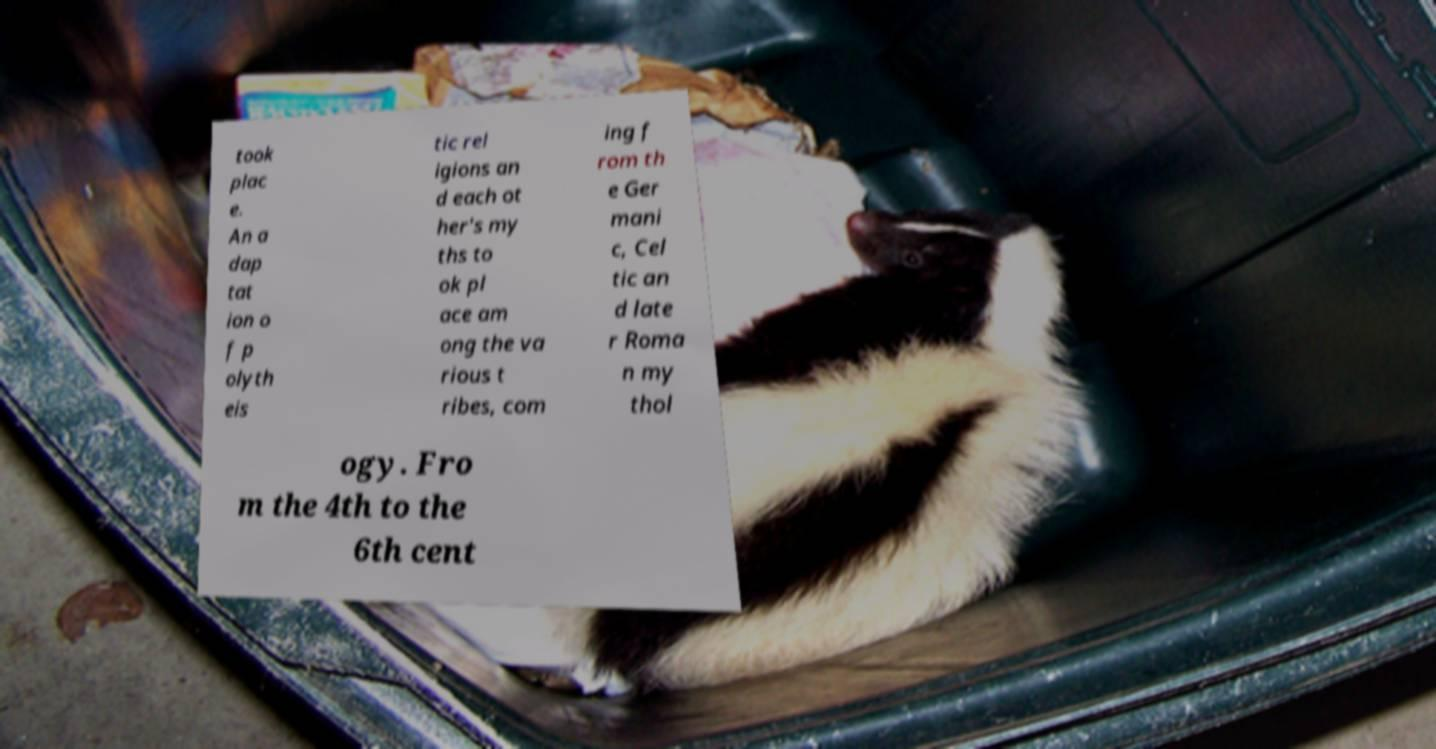There's text embedded in this image that I need extracted. Can you transcribe it verbatim? took plac e. An a dap tat ion o f p olyth eis tic rel igions an d each ot her's my ths to ok pl ace am ong the va rious t ribes, com ing f rom th e Ger mani c, Cel tic an d late r Roma n my thol ogy. Fro m the 4th to the 6th cent 